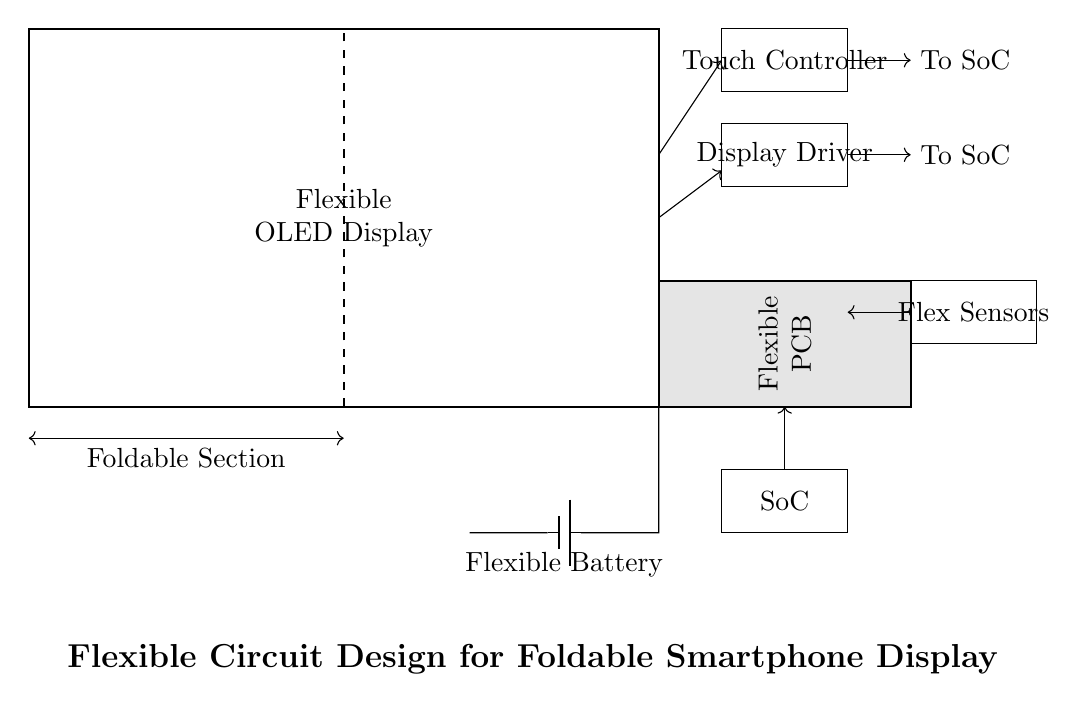What is the main component of the flexible circuit? The main component is the Flexible OLED Display, which is visually prominent in the circuit as a large rectangle labeled "Flexible OLED Display."
Answer: Flexible OLED Display What type of battery is used in this design? The design uses a Flexible Battery, indicated by the label next to the battery symbol located at the bottom of the circuit.
Answer: Flexible Battery How many sensors are included in the circuit? There is one set of Flex Sensors, represented as a rectangular block labeled "Flex Sensors" connected in the circuit.
Answer: One What component connects to the System-on-Chip? The Touch Controller and Display Driver both connect to the System-on-Chip, as shown by arrows leading towards a connection marked "To SoC."
Answer: Touch Controller and Display Driver What is the purpose of the Flexible PCB? The Flexible PCB serves as the interconnect for the components, as indicated by its position and label in the circuit. It allows the other components to connect and communicate.
Answer: Interconnect for components How is the display driver powered? The Display Driver is powered through an arrow connection from the Flexible PCB, specifically indicating that it receives power from this source.
Answer: From the Flexible PCB What is the folding mechanism represented by? The folding mechanism is represented by the dashed line dividing the Flexible OLED Display, indicating where it can flex or fold.
Answer: Dashed line 